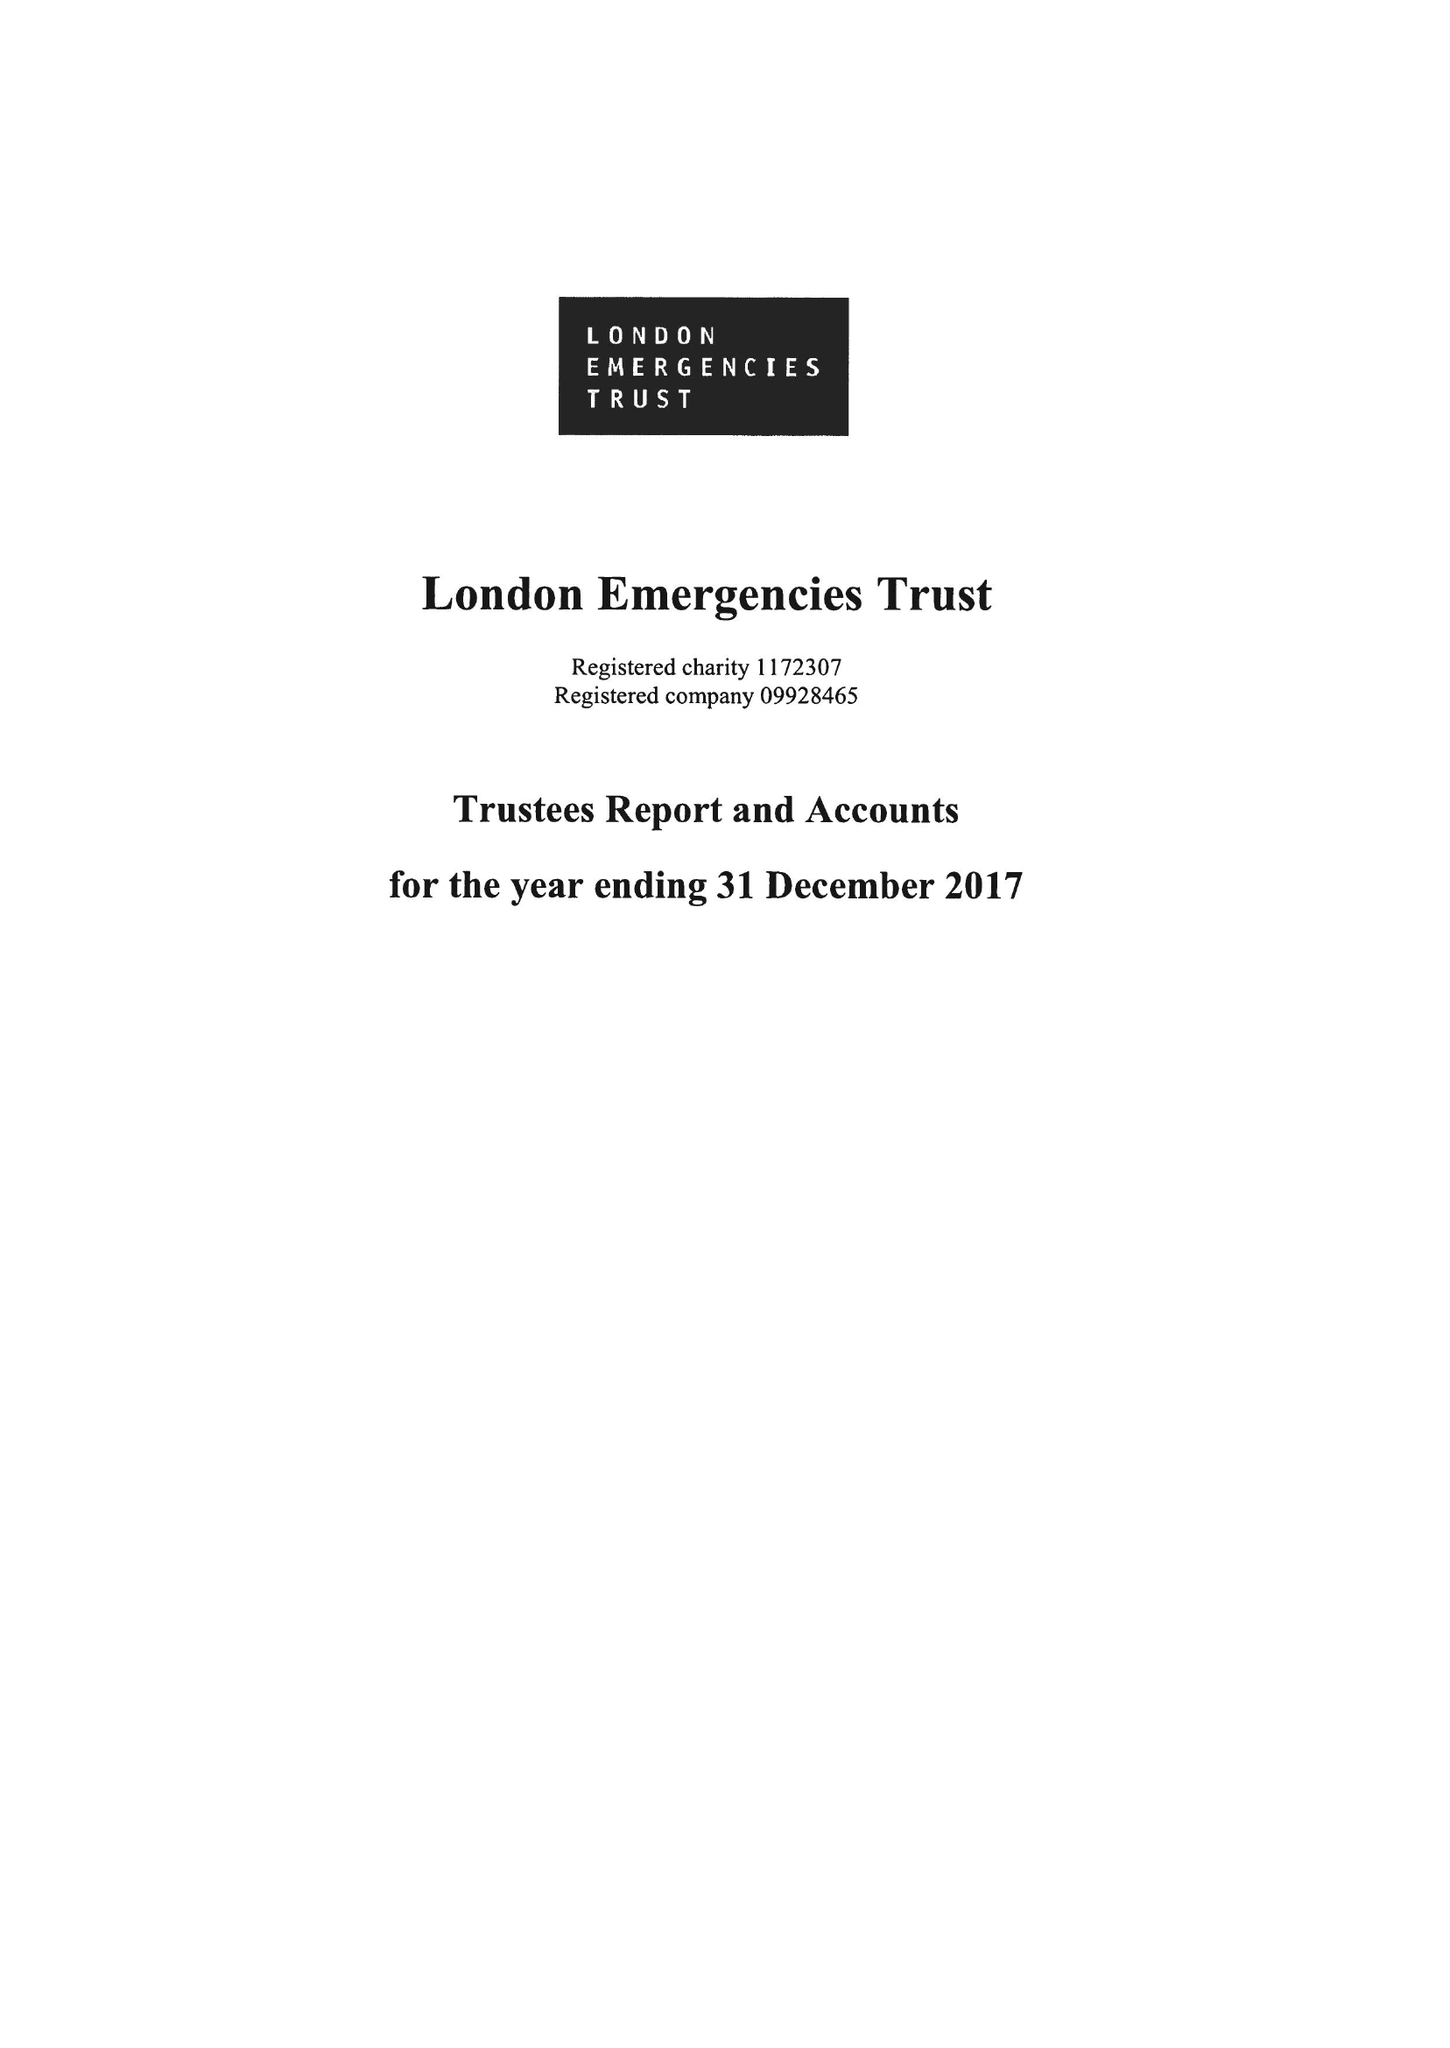What is the value for the charity_number?
Answer the question using a single word or phrase. 1172307 